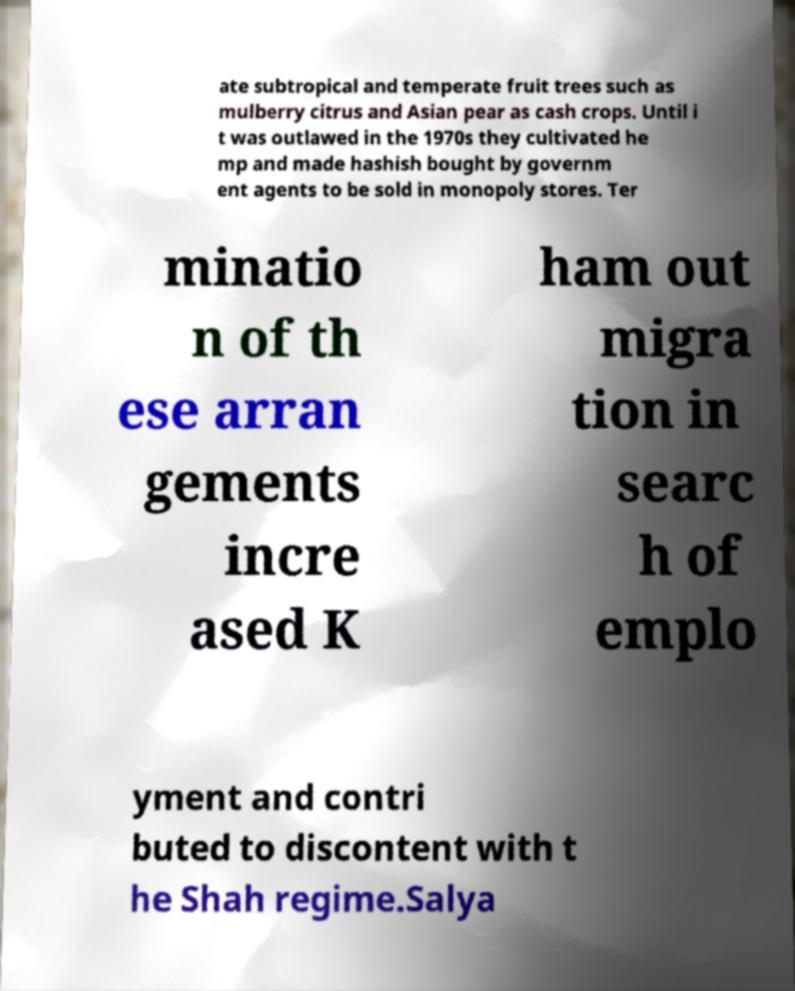Please read and relay the text visible in this image. What does it say? ate subtropical and temperate fruit trees such as mulberry citrus and Asian pear as cash crops. Until i t was outlawed in the 1970s they cultivated he mp and made hashish bought by governm ent agents to be sold in monopoly stores. Ter minatio n of th ese arran gements incre ased K ham out migra tion in searc h of emplo yment and contri buted to discontent with t he Shah regime.Salya 